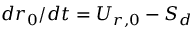Convert formula to latex. <formula><loc_0><loc_0><loc_500><loc_500>{ d r _ { 0 } } / { d t } = U _ { r , 0 } - S _ { d }</formula> 